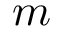Convert formula to latex. <formula><loc_0><loc_0><loc_500><loc_500>m</formula> 